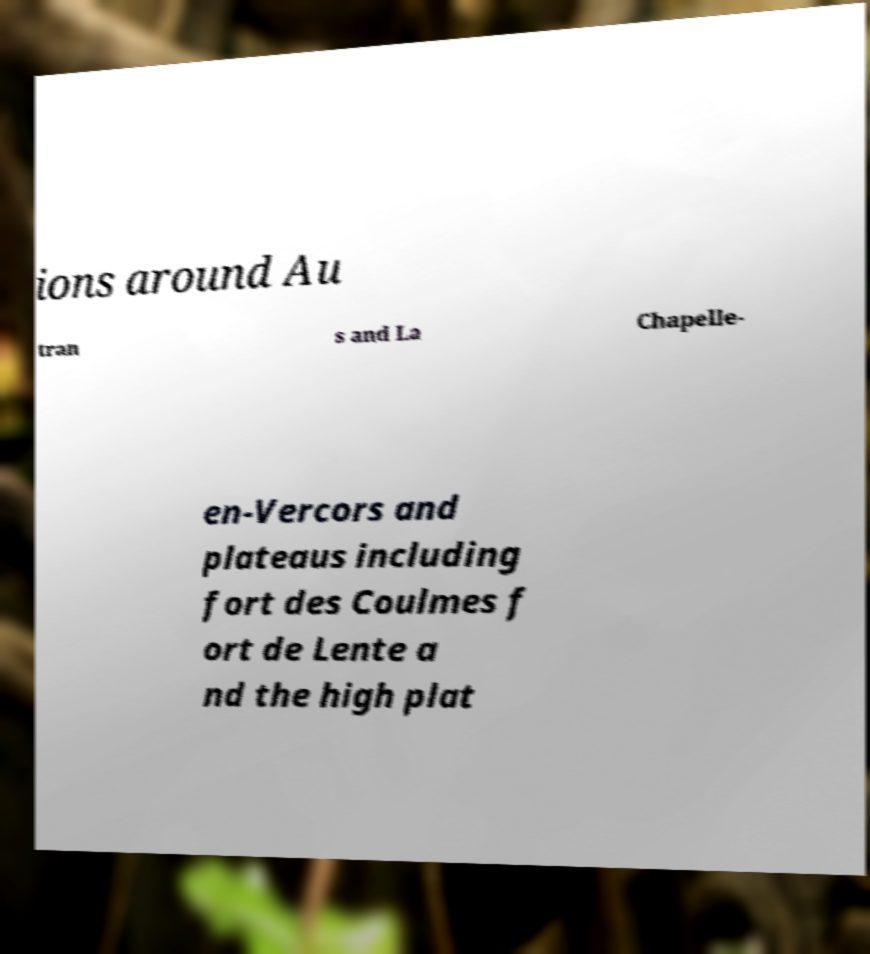Could you assist in decoding the text presented in this image and type it out clearly? ions around Au tran s and La Chapelle- en-Vercors and plateaus including fort des Coulmes f ort de Lente a nd the high plat 